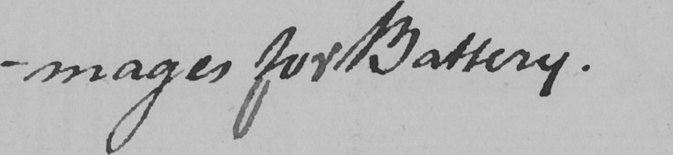What is written in this line of handwriting? -mages for Battery . 